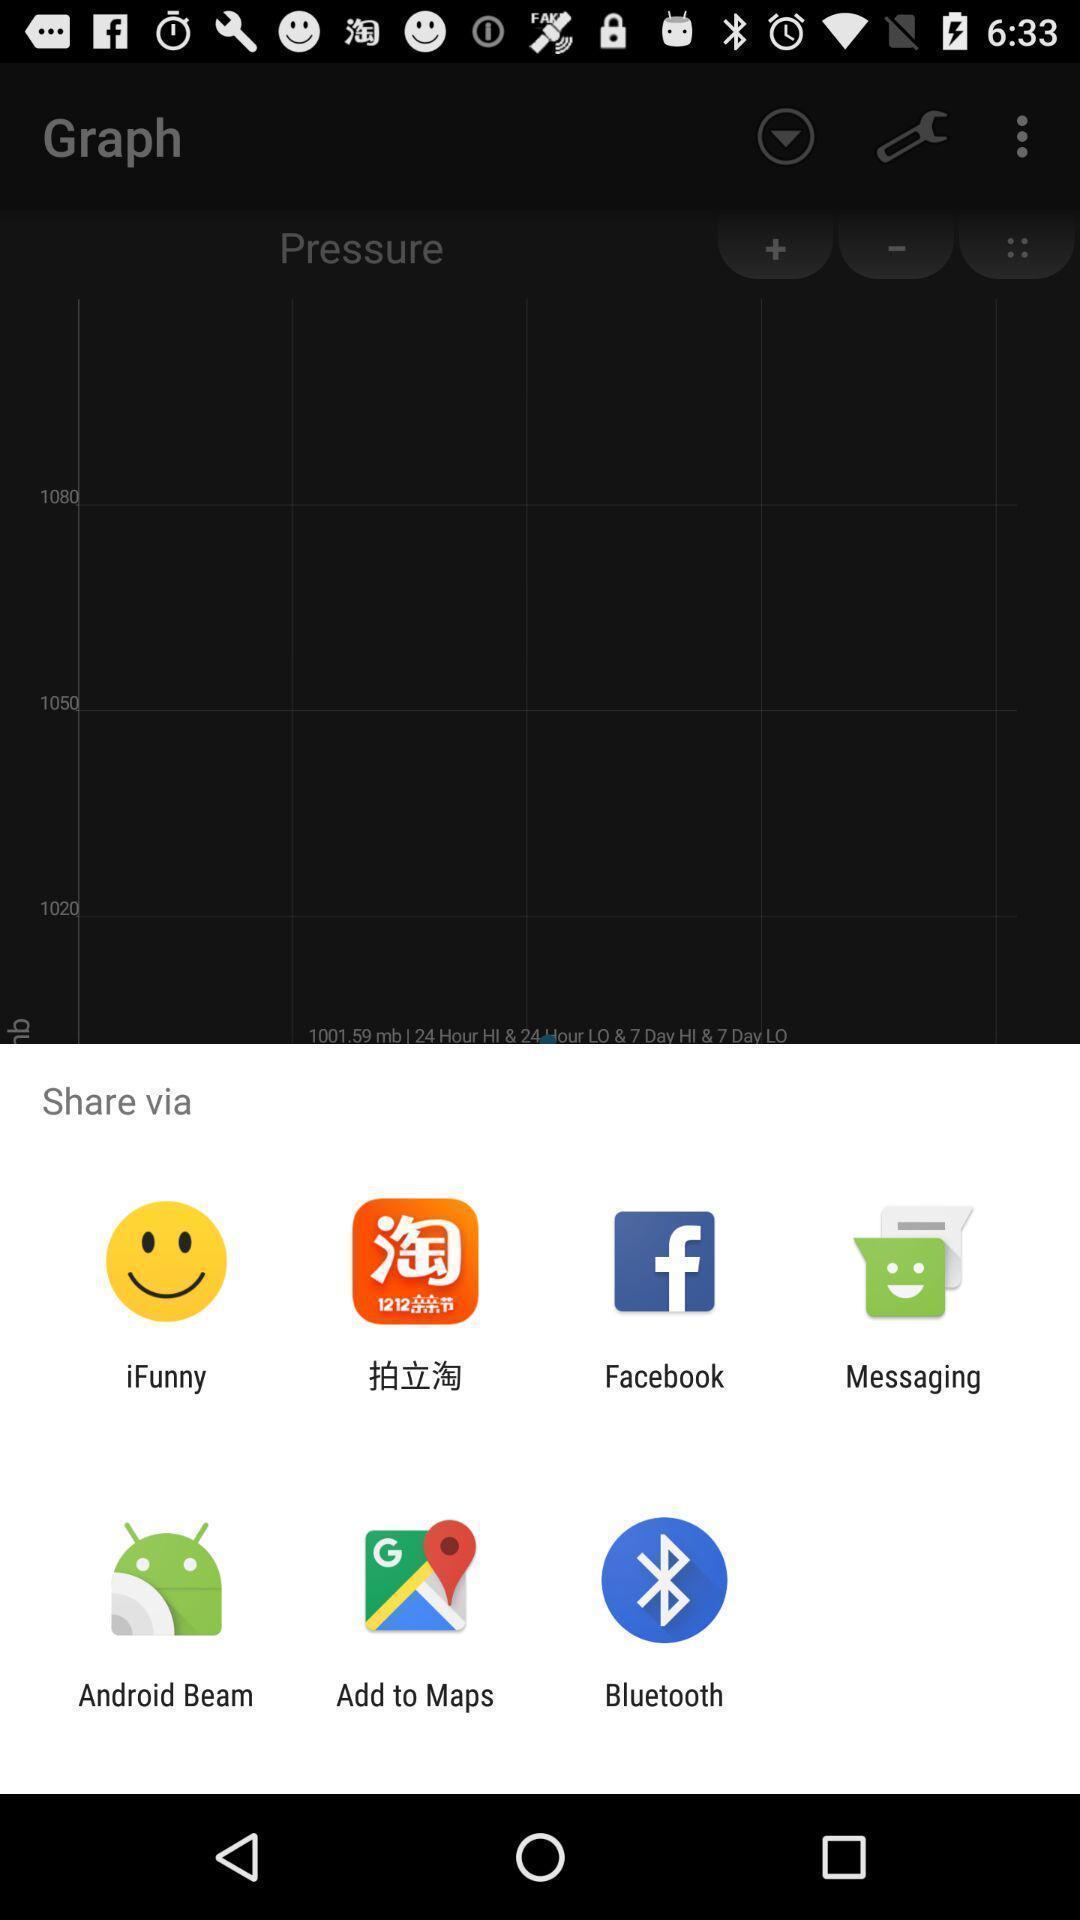Provide a description of this screenshot. Pop-up showing various sharing options. 